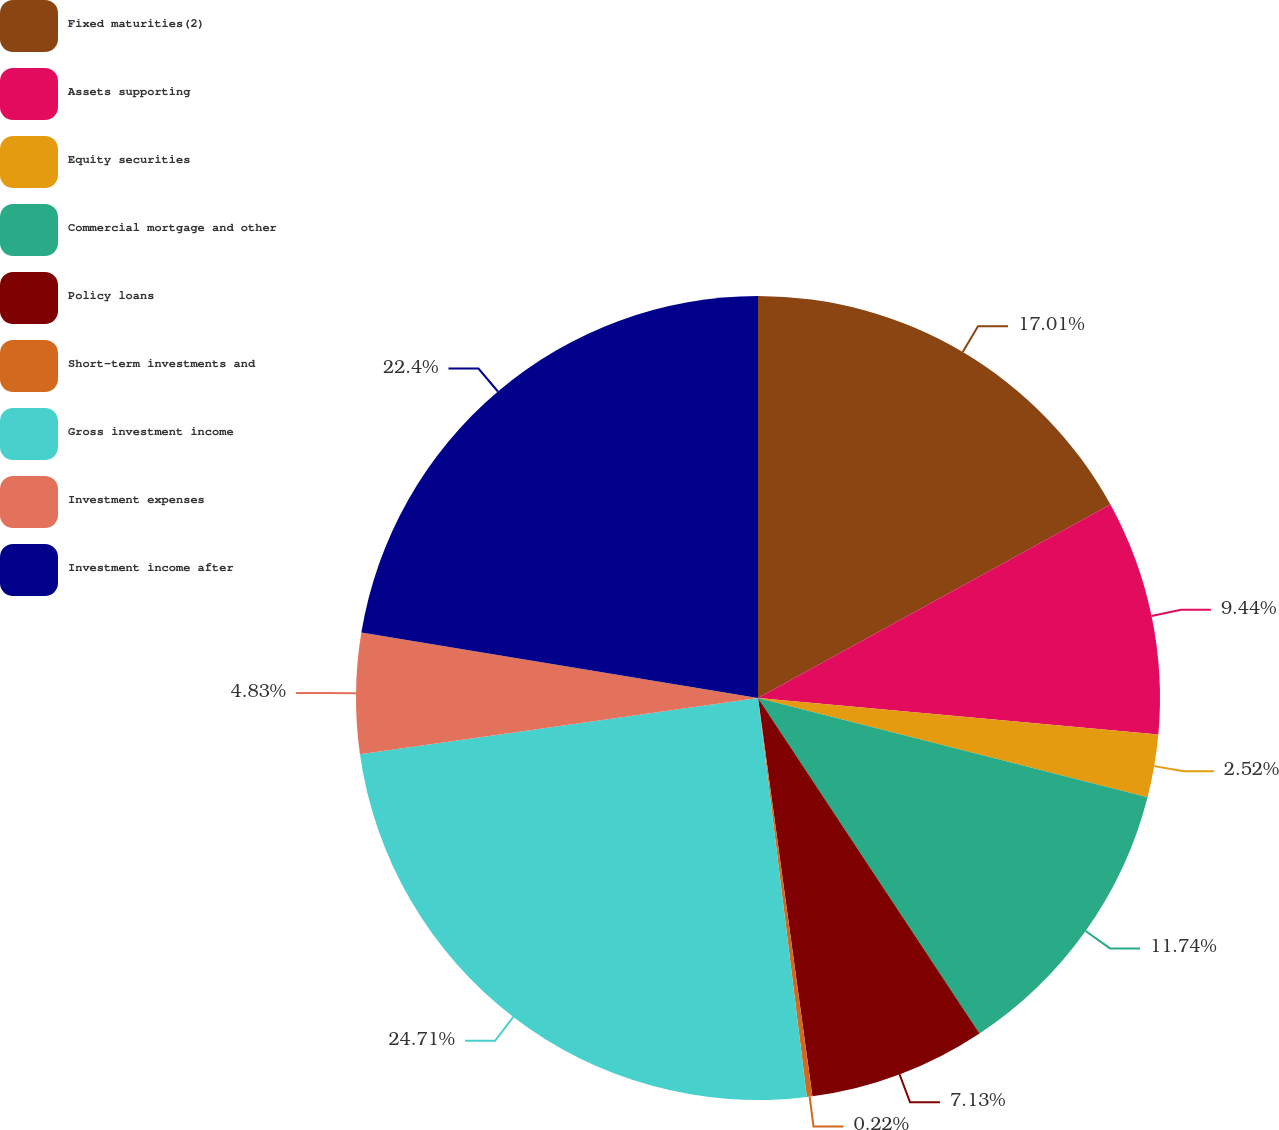Convert chart to OTSL. <chart><loc_0><loc_0><loc_500><loc_500><pie_chart><fcel>Fixed maturities(2)<fcel>Assets supporting<fcel>Equity securities<fcel>Commercial mortgage and other<fcel>Policy loans<fcel>Short-term investments and<fcel>Gross investment income<fcel>Investment expenses<fcel>Investment income after<nl><fcel>17.01%<fcel>9.44%<fcel>2.52%<fcel>11.74%<fcel>7.13%<fcel>0.22%<fcel>24.71%<fcel>4.83%<fcel>22.4%<nl></chart> 